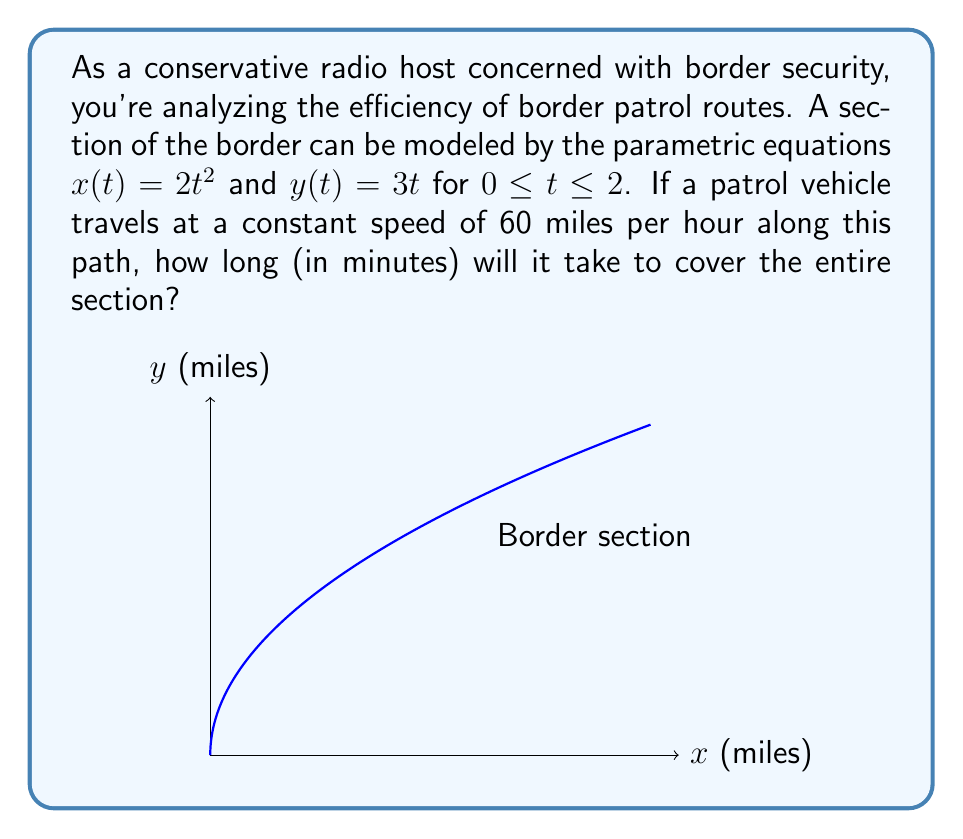Can you solve this math problem? To solve this problem, we need to follow these steps:

1) First, we need to find the length of the path. For parametric equations, we can use the arc length formula:

   $$L = \int_a^b \sqrt{\left(\frac{dx}{dt}\right)^2 + \left(\frac{dy}{dt}\right)^2} dt$$

2) We need to find $\frac{dx}{dt}$ and $\frac{dy}{dt}$:
   
   $\frac{dx}{dt} = 4t$
   $\frac{dy}{dt} = 3$

3) Substituting into the arc length formula:

   $$L = \int_0^2 \sqrt{(4t)^2 + 3^2} dt = \int_0^2 \sqrt{16t^2 + 9} dt$$

4) This integral is complicated to solve analytically. We can use a calculator or computer to evaluate it numerically. The result is approximately 7.2649 miles.

5) Now that we have the length, we can calculate the time needed to travel this distance at 60 mph:

   $\text{Time (hours)} = \frac{\text{Distance}}{\text{Speed}} = \frac{7.2649}{60} \approx 0.1211$ hours

6) Convert this to minutes:

   $\text{Time (minutes)} = 0.1211 * 60 \approx 7.2660$ minutes

Therefore, it will take approximately 7.27 minutes to cover the entire section.
Answer: 7.27 minutes 